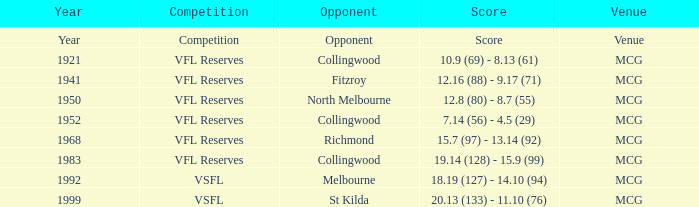Where did a competitive event take place with a score documented as MCG. 